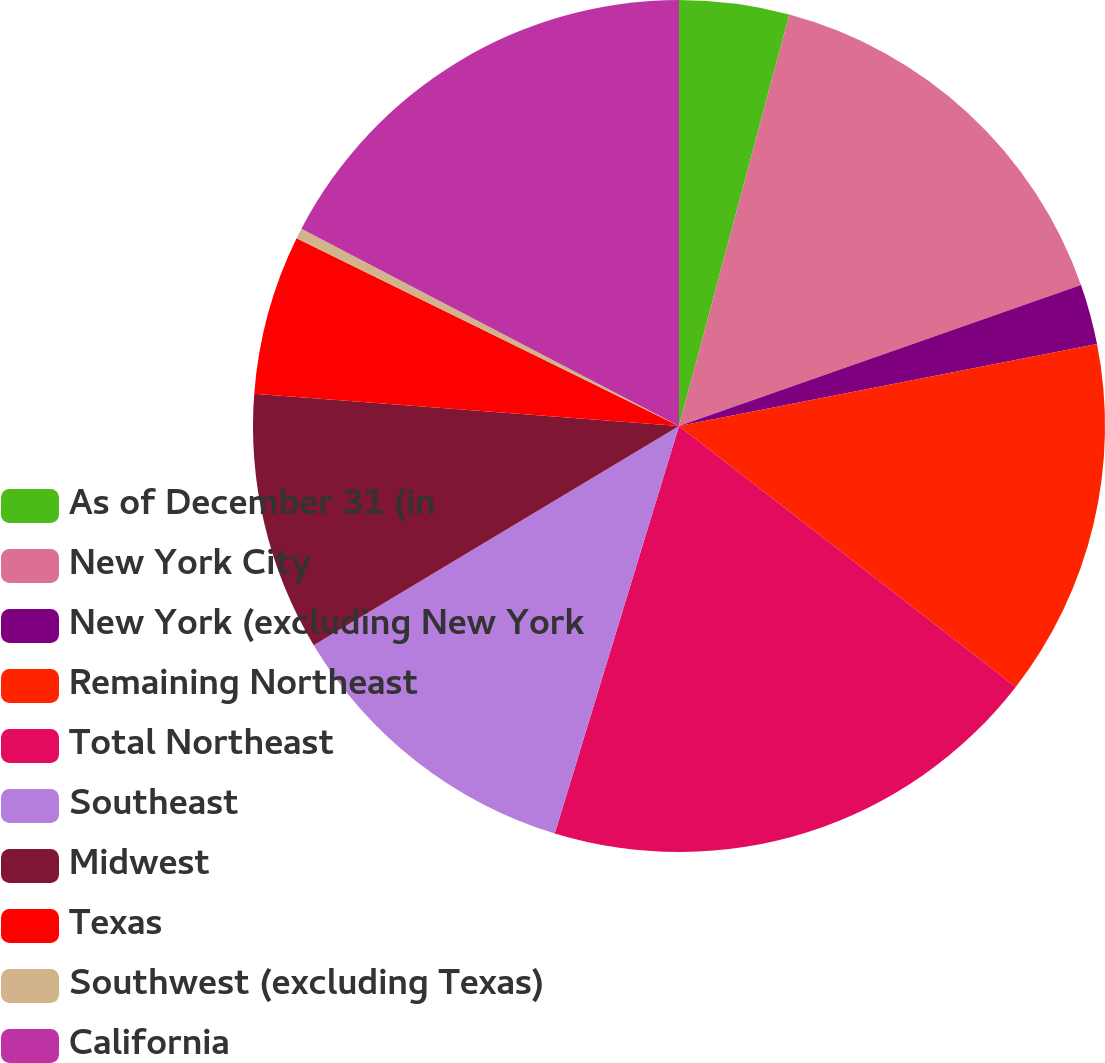Convert chart. <chart><loc_0><loc_0><loc_500><loc_500><pie_chart><fcel>As of December 31 (in<fcel>New York City<fcel>New York (excluding New York<fcel>Remaining Northeast<fcel>Total Northeast<fcel>Southeast<fcel>Midwest<fcel>Texas<fcel>Southwest (excluding Texas)<fcel>California<nl><fcel>4.17%<fcel>15.46%<fcel>2.29%<fcel>13.57%<fcel>19.22%<fcel>11.69%<fcel>9.81%<fcel>6.05%<fcel>0.4%<fcel>17.34%<nl></chart> 